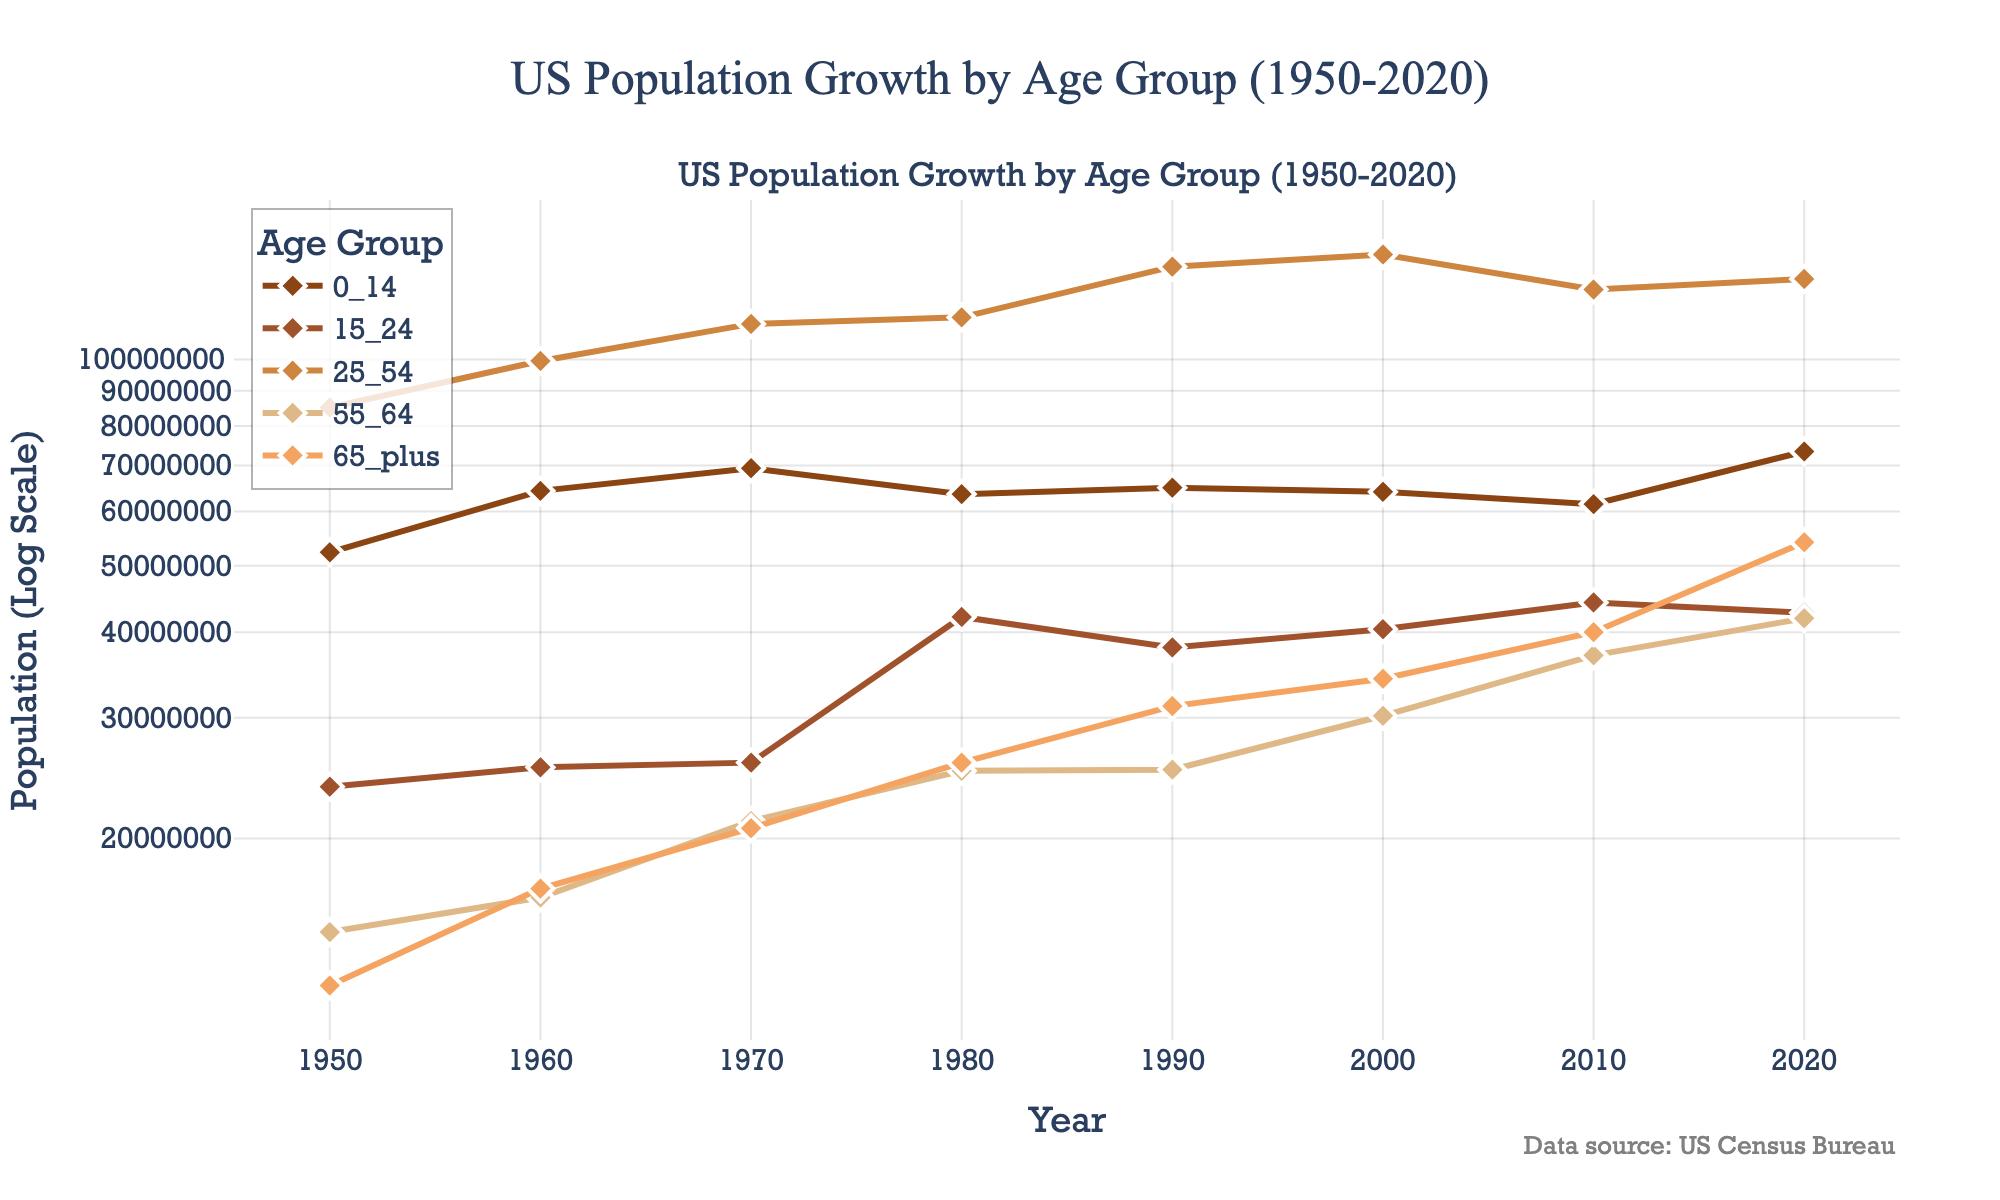How many age groups are represented in the figure? The figure has a legend that lists the different age groups. By counting the entries in the legend, you can see there are five age groups: 0-14, 15-24, 25-54, 55-64, and 65 plus.
Answer: 5 Which age group had the highest population in 1980? Look for the year 1980 on the x-axis and identify the highest y-value among the data points for all the age groups. The 25-54 age group has the highest point.
Answer: 25-54 What is the trend for the Population_65_plus group over the years? Observe the line corresponding to the Population_65_plus group from 1950 to 2020. The trend shows a consistent increase in population.
Answer: Increasing What was the population for the Population_0_14 group in 1990? Find the year 1990 on the x-axis and locate the corresponding data point for the Population_0_14 group by looking at the respective line. The population is 65,000,000.
Answer: 65,000,000 Compare the population growth of the Population_25_54 group between 1950 and 2020. Look at the population values for the Population_25_54 group in 1950 and 2020. The values are 85,100,000 in 1950 and 131,100,000 in 2020. Calculating the difference, the population of this group has increased by 46,000,000.
Answer: Increased by 46,000,000 Which year did the Population_15_24 group have its highest population? Scan across the years on the x-axis to see when the Population_15_24 group peaked. It peaks in 2010 with 44,200,000.
Answer: 2010 What is the general pattern observed for the Population_55_64 group? Follow the Population_55_64 line from 1950 to 2020. The pattern starts with a steady increase, with a notable rise from 2000 onwards.
Answer: Steady increase with a notable rise post-2000 What is the difference in population between the Population_25_54 and Population_65_plus groups in 2020? For 2020, find the values for Population_25_54 and Population_65_plus. The Population_25_54 is 131,100,000, and Population_65_plus is 54,100,000. Subtracting these (131,100,000 - 54,100,000) gives 77,000,000.
Answer: 77,000,000 